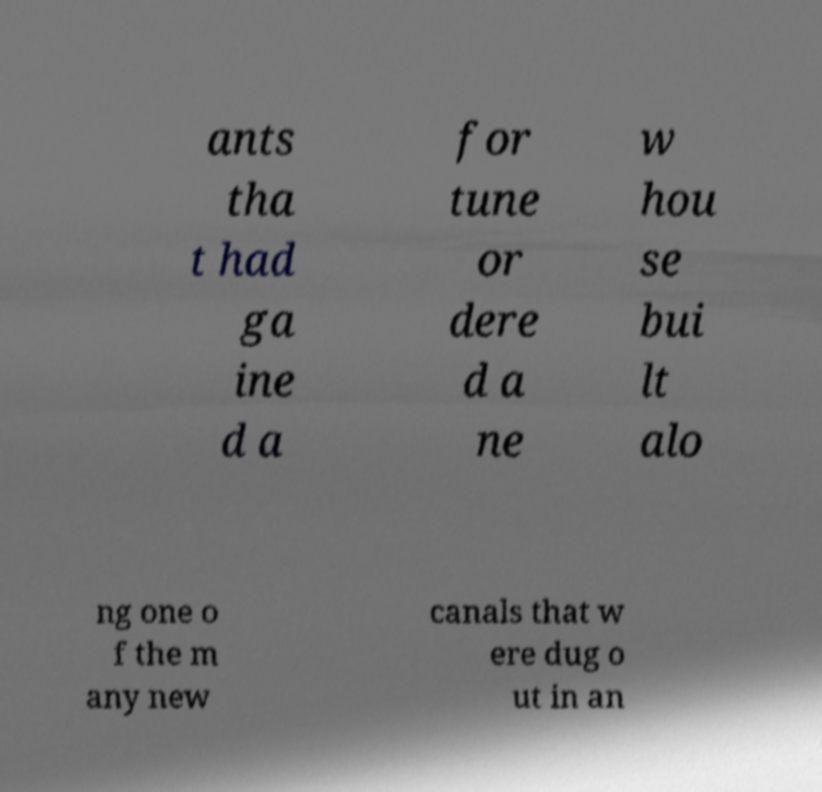Can you read and provide the text displayed in the image?This photo seems to have some interesting text. Can you extract and type it out for me? ants tha t had ga ine d a for tune or dere d a ne w hou se bui lt alo ng one o f the m any new canals that w ere dug o ut in an 